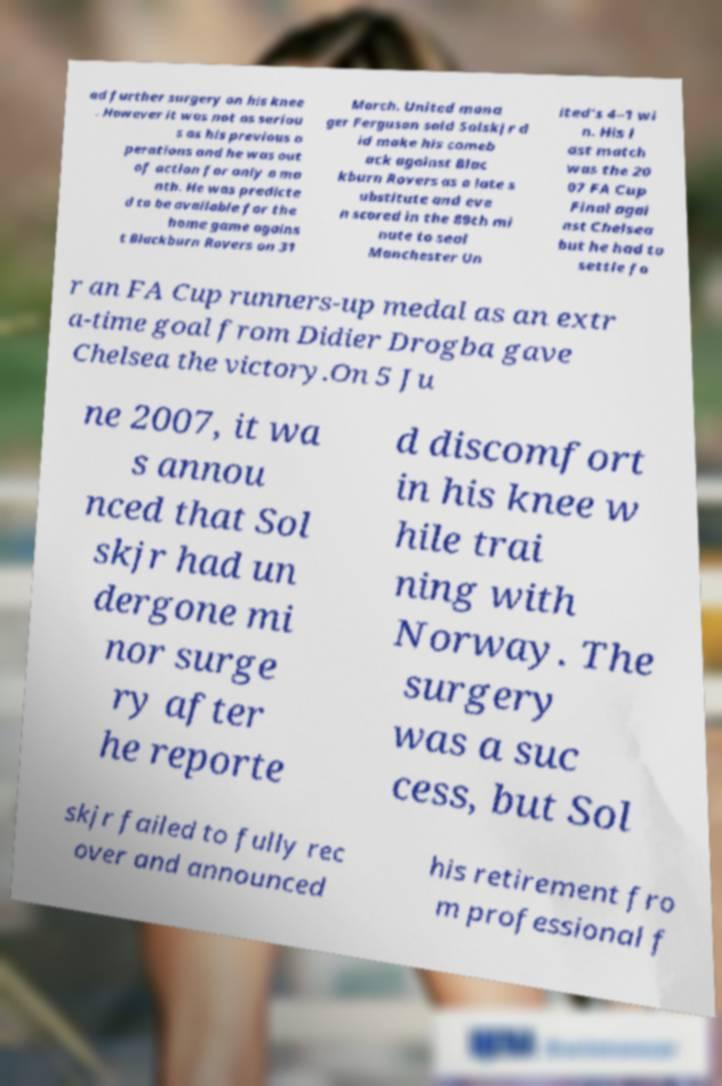Can you read and provide the text displayed in the image?This photo seems to have some interesting text. Can you extract and type it out for me? ad further surgery on his knee . However it was not as seriou s as his previous o perations and he was out of action for only a mo nth. He was predicte d to be available for the home game agains t Blackburn Rovers on 31 March. United mana ger Ferguson said Solskjr d id make his comeb ack against Blac kburn Rovers as a late s ubstitute and eve n scored in the 89th mi nute to seal Manchester Un ited's 4–1 wi n. His l ast match was the 20 07 FA Cup Final agai nst Chelsea but he had to settle fo r an FA Cup runners-up medal as an extr a-time goal from Didier Drogba gave Chelsea the victory.On 5 Ju ne 2007, it wa s annou nced that Sol skjr had un dergone mi nor surge ry after he reporte d discomfort in his knee w hile trai ning with Norway. The surgery was a suc cess, but Sol skjr failed to fully rec over and announced his retirement fro m professional f 